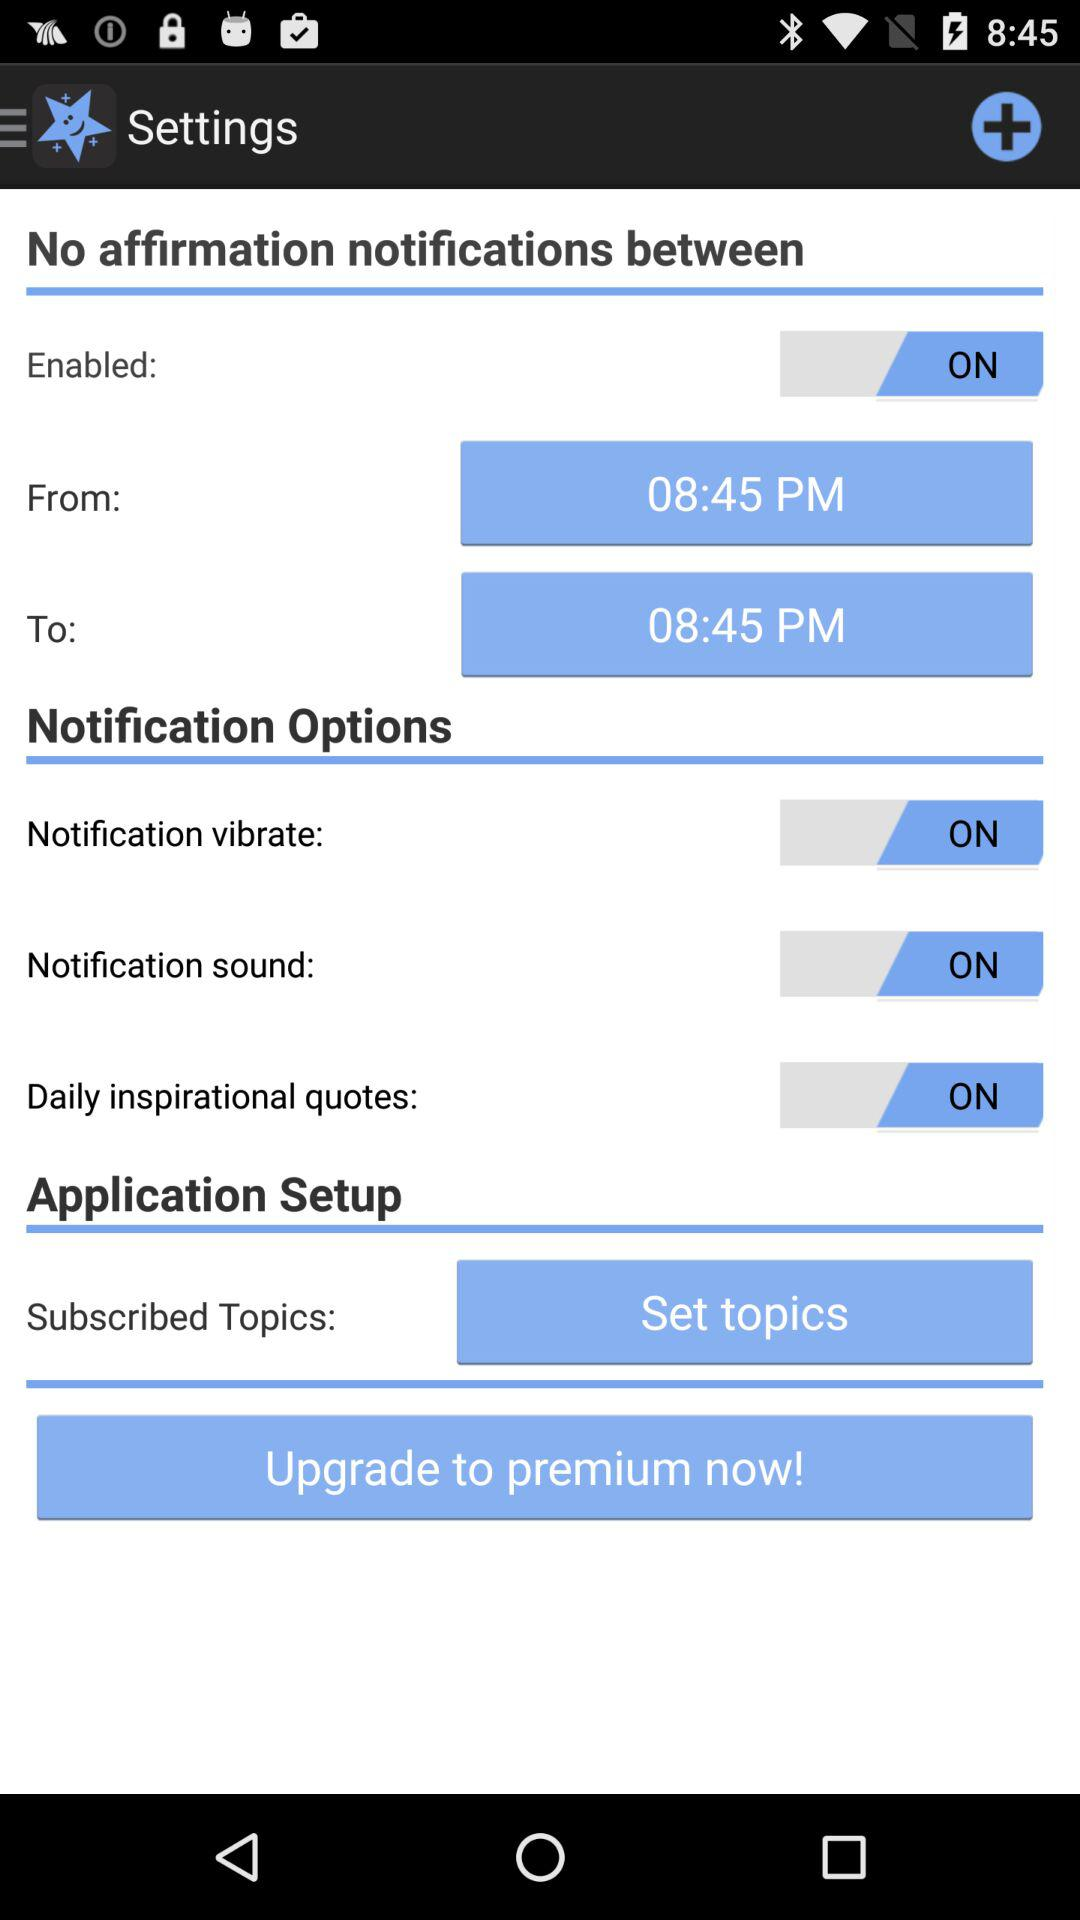What is the status of "Notification vibrate"? The status is "on". 